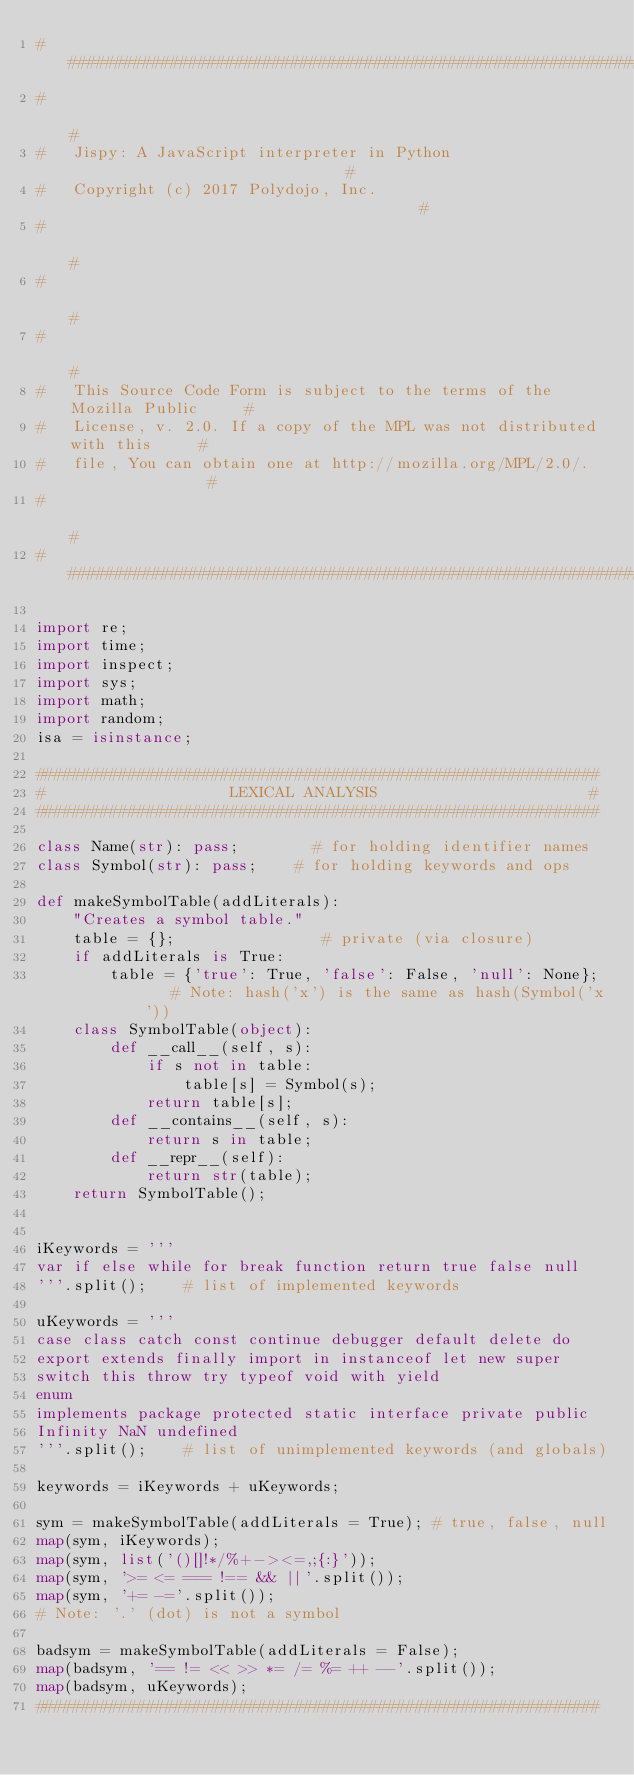Convert code to text. <code><loc_0><loc_0><loc_500><loc_500><_Python_>#############################################################################
#                                                                           #
#   Jispy: A JavaScript interpreter in Python                               #
#   Copyright (c) 2017 Polydojo, Inc.                                       #
#                                                                           #
#                                                                           #
#                                                                           #
#   This Source Code Form is subject to the terms of the Mozilla Public     #
#   License, v. 2.0. If a copy of the MPL was not distributed with this     #
#   file, You can obtain one at http://mozilla.org/MPL/2.0/.                #
#                                                                           #
#############################################################################

import re;
import time;
import inspect;
import sys;
import math;
import random;
isa = isinstance;

#############################################################
#                    LEXICAL ANALYSIS                       #
#############################################################

class Name(str): pass;        # for holding identifier names
class Symbol(str): pass;    # for holding keywords and ops

def makeSymbolTable(addLiterals):
    "Creates a symbol table."
    table = {};                # private (via closure)
    if addLiterals is True:
        table = {'true': True, 'false': False, 'null': None};    # Note: hash('x') is the same as hash(Symbol('x'))
    class SymbolTable(object):
        def __call__(self, s):
            if s not in table:
                table[s] = Symbol(s);
            return table[s];
        def __contains__(self, s):
            return s in table;
        def __repr__(self):
            return str(table);
    return SymbolTable();


iKeywords = '''
var if else while for break function return true false null
'''.split();    # list of implemented keywords

uKeywords = '''
case class catch const continue debugger default delete do
export extends finally import in instanceof let new super
switch this throw try typeof void with yield
enum
implements package protected static interface private public
Infinity NaN undefined
'''.split();    # list of unimplemented keywords (and globals)

keywords = iKeywords + uKeywords;

sym = makeSymbolTable(addLiterals = True); # true, false, null
map(sym, iKeywords);
map(sym, list('()[]!*/%+-><=,;{:}'));
map(sym, '>= <= === !== && ||'.split());
map(sym, '+= -='.split());
# Note: '.' (dot) is not a symbol

badsym = makeSymbolTable(addLiterals = False);
map(badsym, '== != << >> *= /= %= ++ --'.split());
map(badsym, uKeywords);
#############################################################
</code> 